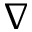<formula> <loc_0><loc_0><loc_500><loc_500>\nabla</formula> 